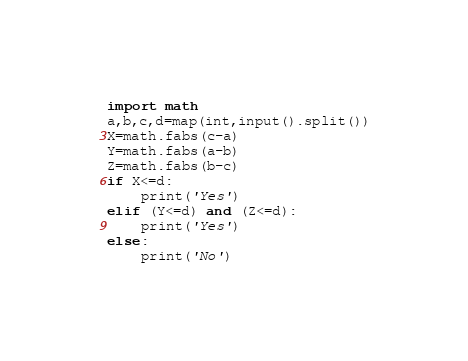Convert code to text. <code><loc_0><loc_0><loc_500><loc_500><_Python_>import math
a,b,c,d=map(int,input().split())
X=math.fabs(c-a)
Y=math.fabs(a-b)
Z=math.fabs(b-c)
if X<=d:
    print('Yes')
elif (Y<=d) and (Z<=d):
    print('Yes')
else:
    print('No')</code> 